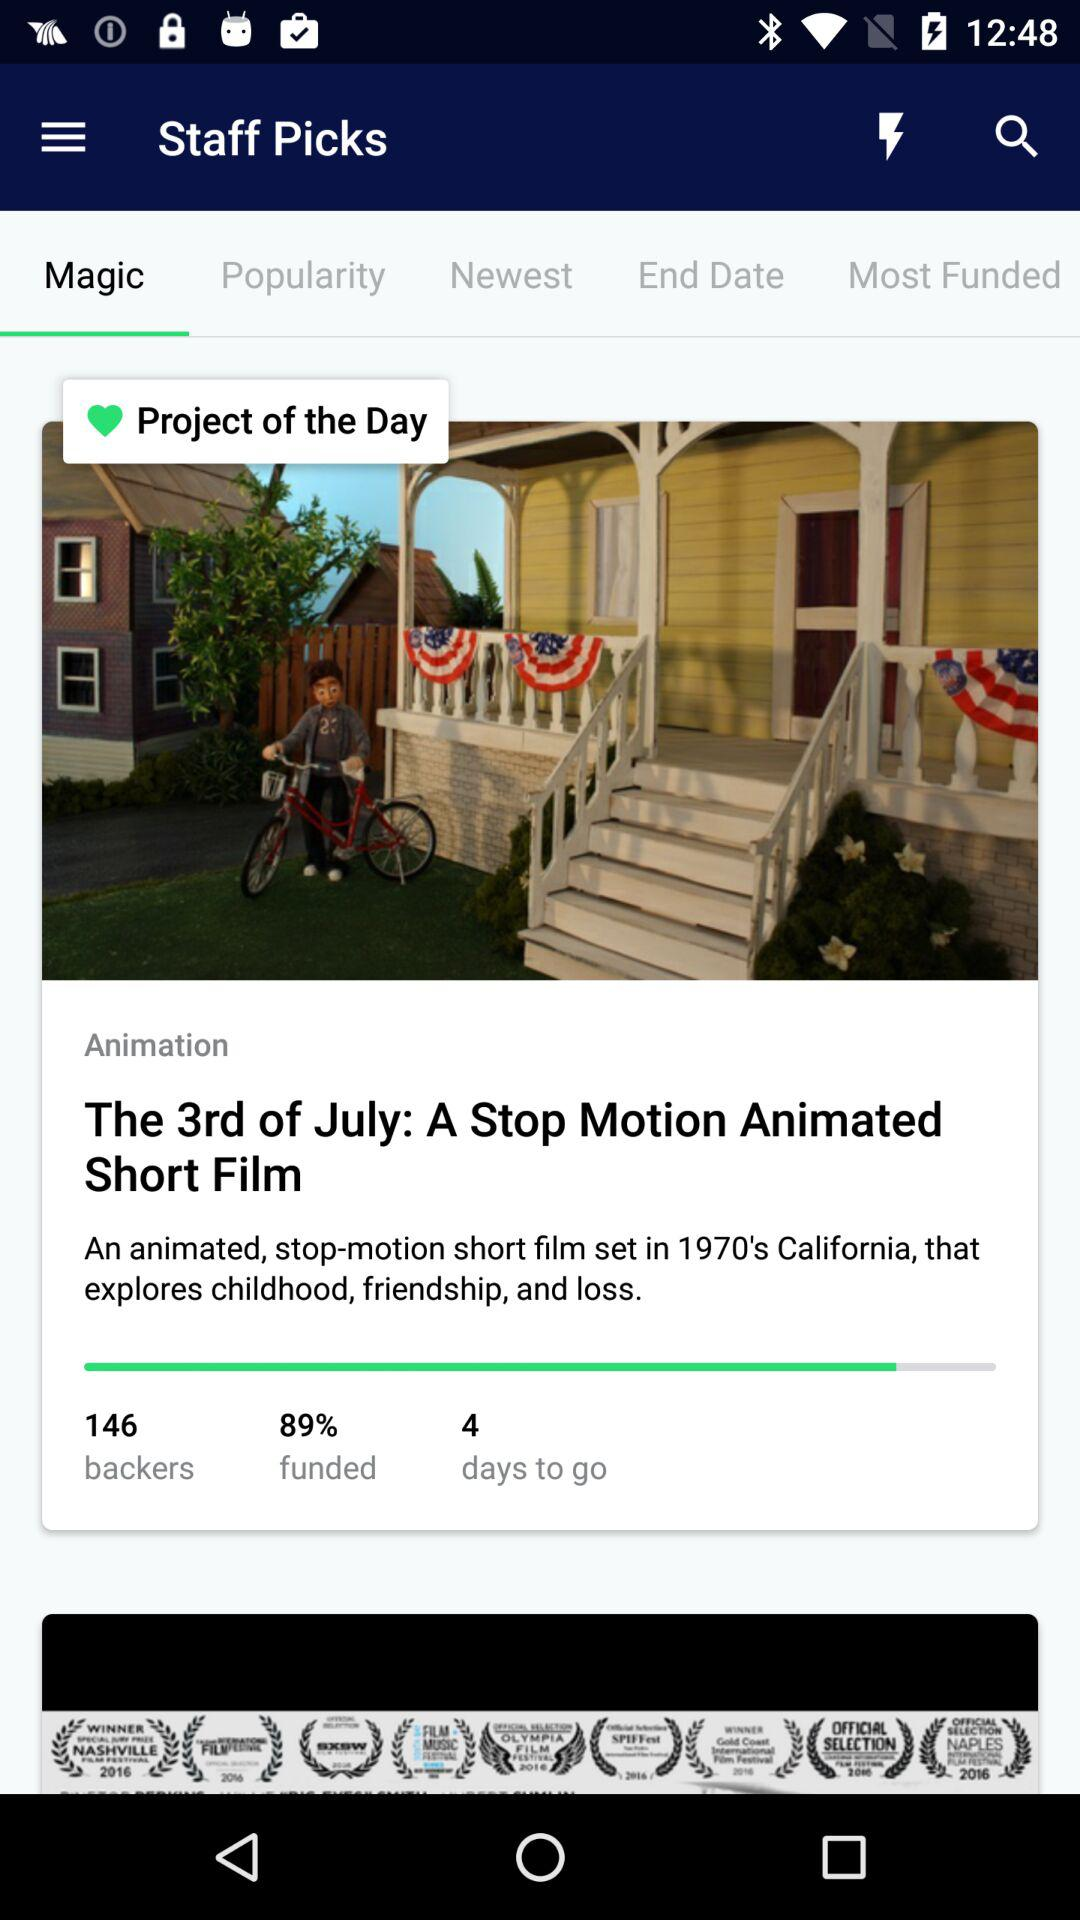How many backers are there for the movie? There are 146 backers for the movie. 